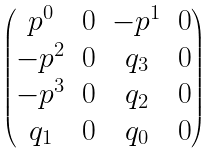<formula> <loc_0><loc_0><loc_500><loc_500>\begin{pmatrix} p ^ { 0 } & 0 & - p ^ { 1 } & 0 \\ - p ^ { 2 } & 0 & q _ { 3 } & 0 \\ - p ^ { 3 } & 0 & q _ { 2 } & 0 \\ q _ { 1 } & 0 & q _ { 0 } & 0 \end{pmatrix}</formula> 